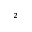<formula> <loc_0><loc_0><loc_500><loc_500>^ { 2 }</formula> 